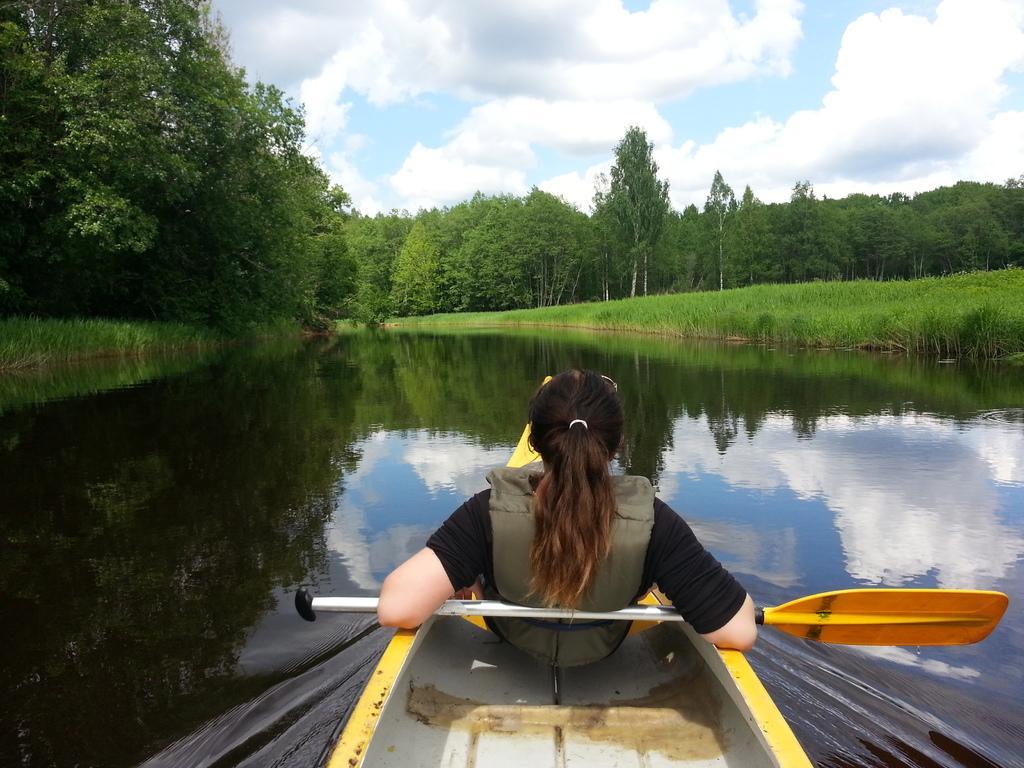How would you summarize this image in a sentence or two? Here in this picture we can see a woman sitting in a boat, which is present in water and we can see is wearing a life jacket and behind her we can see a paddle on which she kept her hands and in the front we can see the ground is fully covered with grass and we can also see plants and trees covered over there and we can see clouds in the sky. 